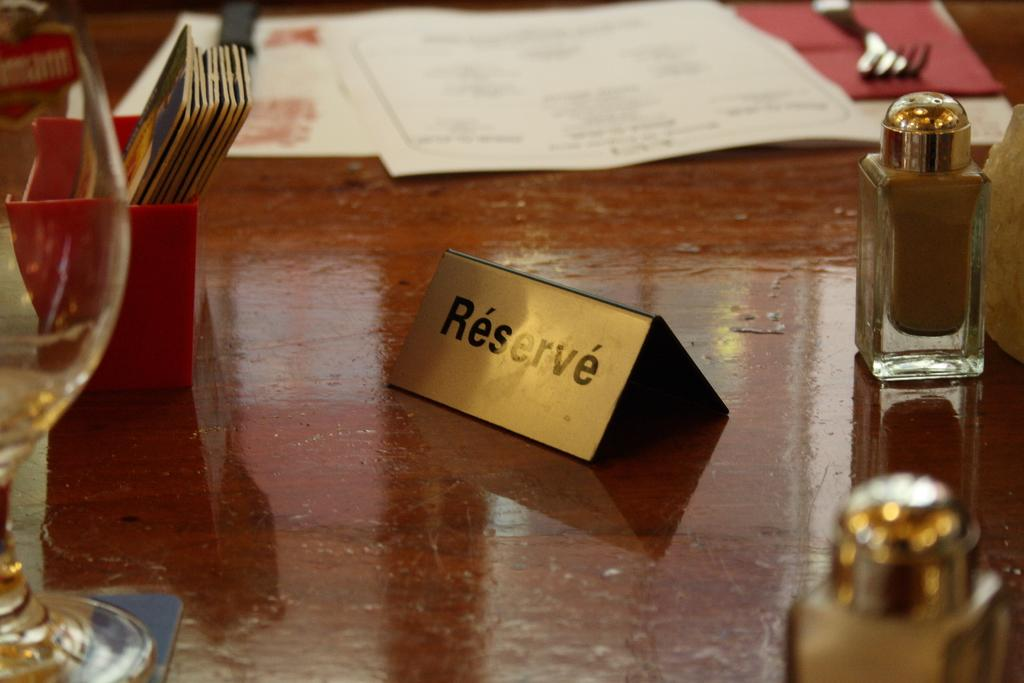<image>
Summarize the visual content of the image. A table set for dining with a gold sign indicating the table is reserved. 